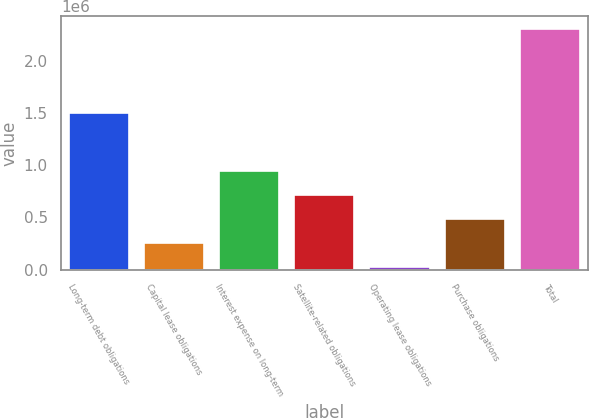Convert chart. <chart><loc_0><loc_0><loc_500><loc_500><bar_chart><fcel>Long-term debt obligations<fcel>Capital lease obligations<fcel>Interest expense on long-term<fcel>Satellite-related obligations<fcel>Operating lease obligations<fcel>Purchase obligations<fcel>Total<nl><fcel>1.50467e+06<fcel>257907<fcel>943103<fcel>714704<fcel>29508<fcel>486305<fcel>2.3135e+06<nl></chart> 